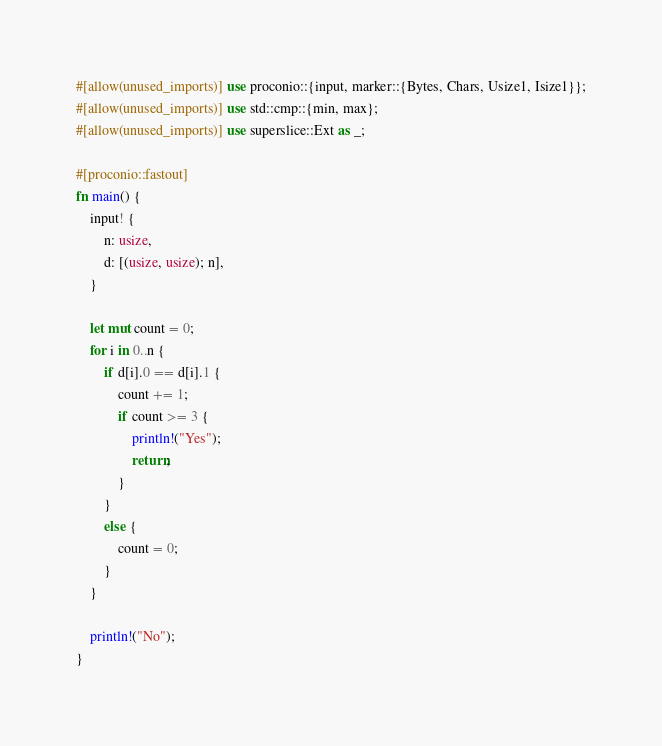<code> <loc_0><loc_0><loc_500><loc_500><_Rust_>#[allow(unused_imports)] use proconio::{input, marker::{Bytes, Chars, Usize1, Isize1}};
#[allow(unused_imports)] use std::cmp::{min, max};
#[allow(unused_imports)] use superslice::Ext as _;

#[proconio::fastout]
fn main() {
	input! {
		n: usize,
		d: [(usize, usize); n],
	}

	let mut count = 0;
	for i in 0..n {
		if d[i].0 == d[i].1 {
			count += 1;
			if count >= 3 {
				println!("Yes");
				return;
			}
		}
		else {
			count = 0;
		}
	}

	println!("No");
}
</code> 